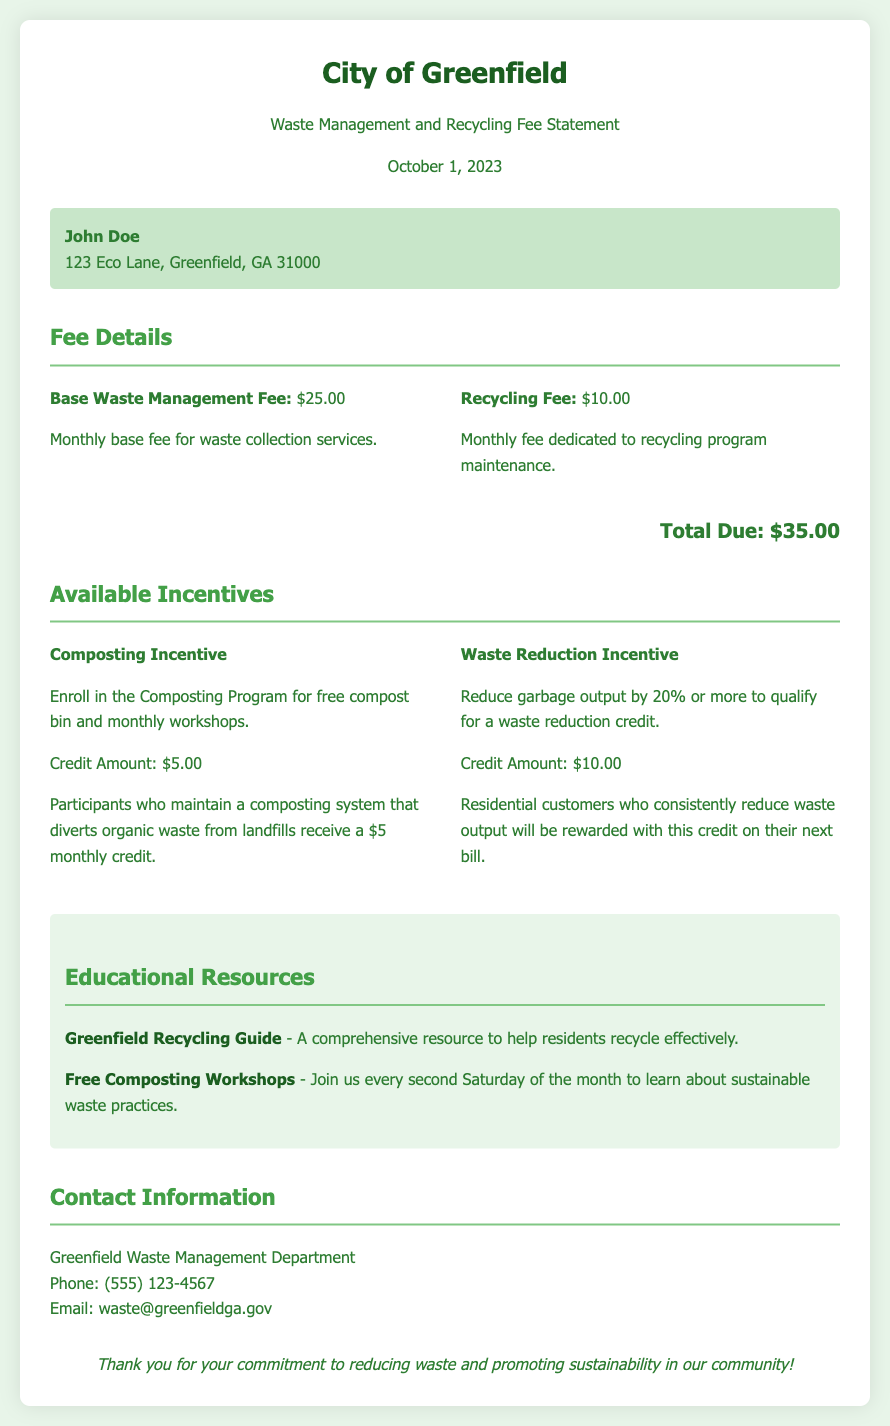What is the base waste management fee? The base waste management fee is specified in the document, which states it is $25.00.
Answer: $25.00 What is the credit amount for the composting incentive? The document lists the credit amount for the composting incentive as $5.00.
Answer: $5.00 What percentage of waste reduction qualifies for the waste reduction incentive? The document states that a reduction of garbage output by 20% or more qualifies for the waste reduction incentive.
Answer: 20% How many credits can a participant earn by maintaining composting? The text explains that participants who maintain a composting system earn a credit of $5.00 monthly.
Answer: $5.00 What is the total amount due according to the statement? The document specifies that the total due amount is calculated as $35.00.
Answer: $35.00 What organization oversees the waste management in Greenfield? The contact information indicates that the Greenfield Waste Management Department oversees the waste management.
Answer: Greenfield Waste Management Department How often are the free composting workshops held? The document mentions that free composting workshops are held every second Saturday of the month.
Answer: Every second Saturday What is the incentive for reducing waste output? The document describes that residents can qualify for a waste reduction credit as an incentive for reducing their waste output.
Answer: Waste reduction credit 